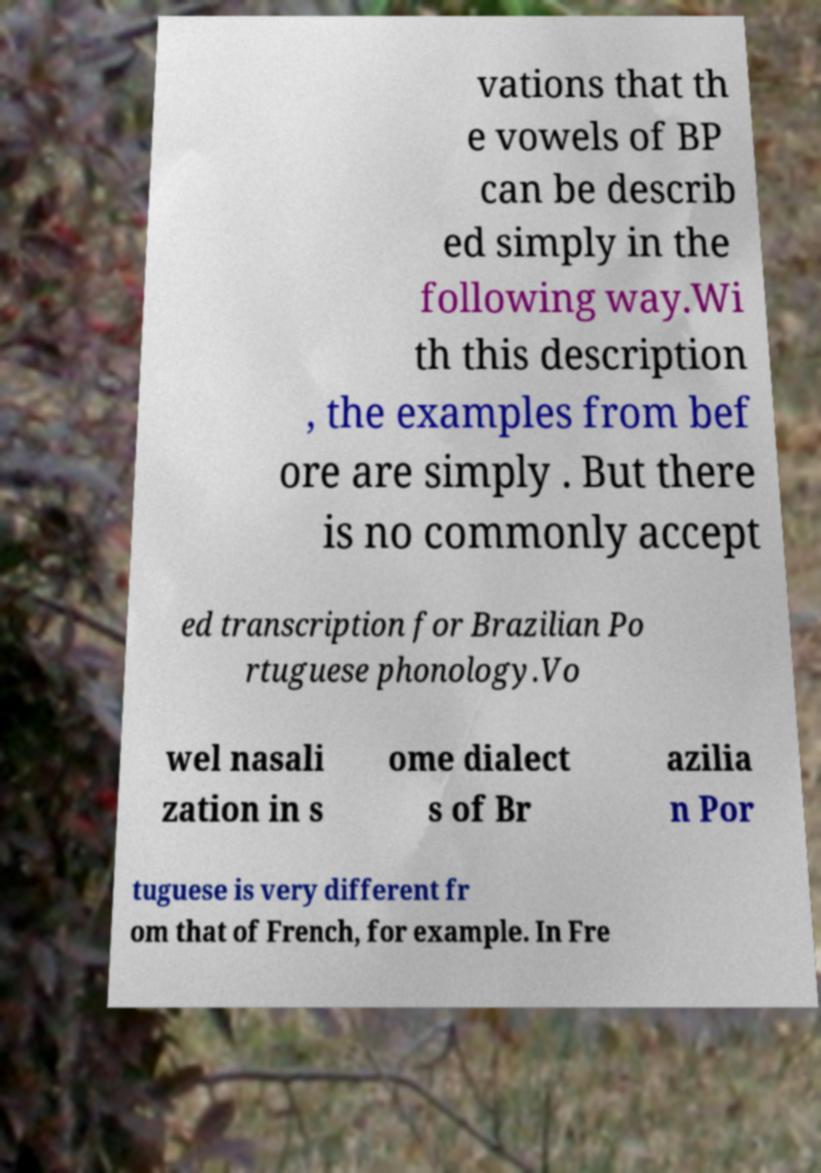There's text embedded in this image that I need extracted. Can you transcribe it verbatim? vations that th e vowels of BP can be describ ed simply in the following way.Wi th this description , the examples from bef ore are simply . But there is no commonly accept ed transcription for Brazilian Po rtuguese phonology.Vo wel nasali zation in s ome dialect s of Br azilia n Por tuguese is very different fr om that of French, for example. In Fre 